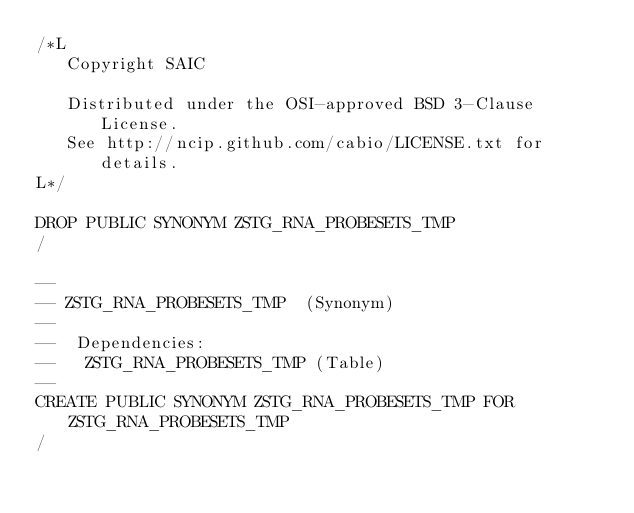Convert code to text. <code><loc_0><loc_0><loc_500><loc_500><_SQL_>/*L
   Copyright SAIC

   Distributed under the OSI-approved BSD 3-Clause License.
   See http://ncip.github.com/cabio/LICENSE.txt for details.
L*/

DROP PUBLIC SYNONYM ZSTG_RNA_PROBESETS_TMP
/

--
-- ZSTG_RNA_PROBESETS_TMP  (Synonym) 
--
--  Dependencies: 
--   ZSTG_RNA_PROBESETS_TMP (Table)
--
CREATE PUBLIC SYNONYM ZSTG_RNA_PROBESETS_TMP FOR ZSTG_RNA_PROBESETS_TMP
/


</code> 